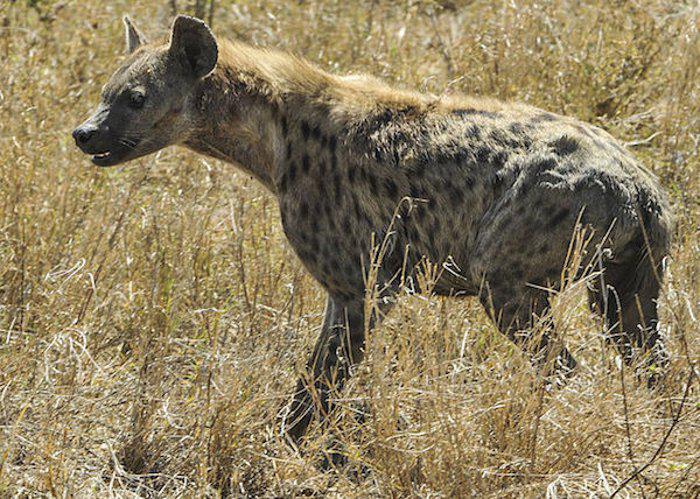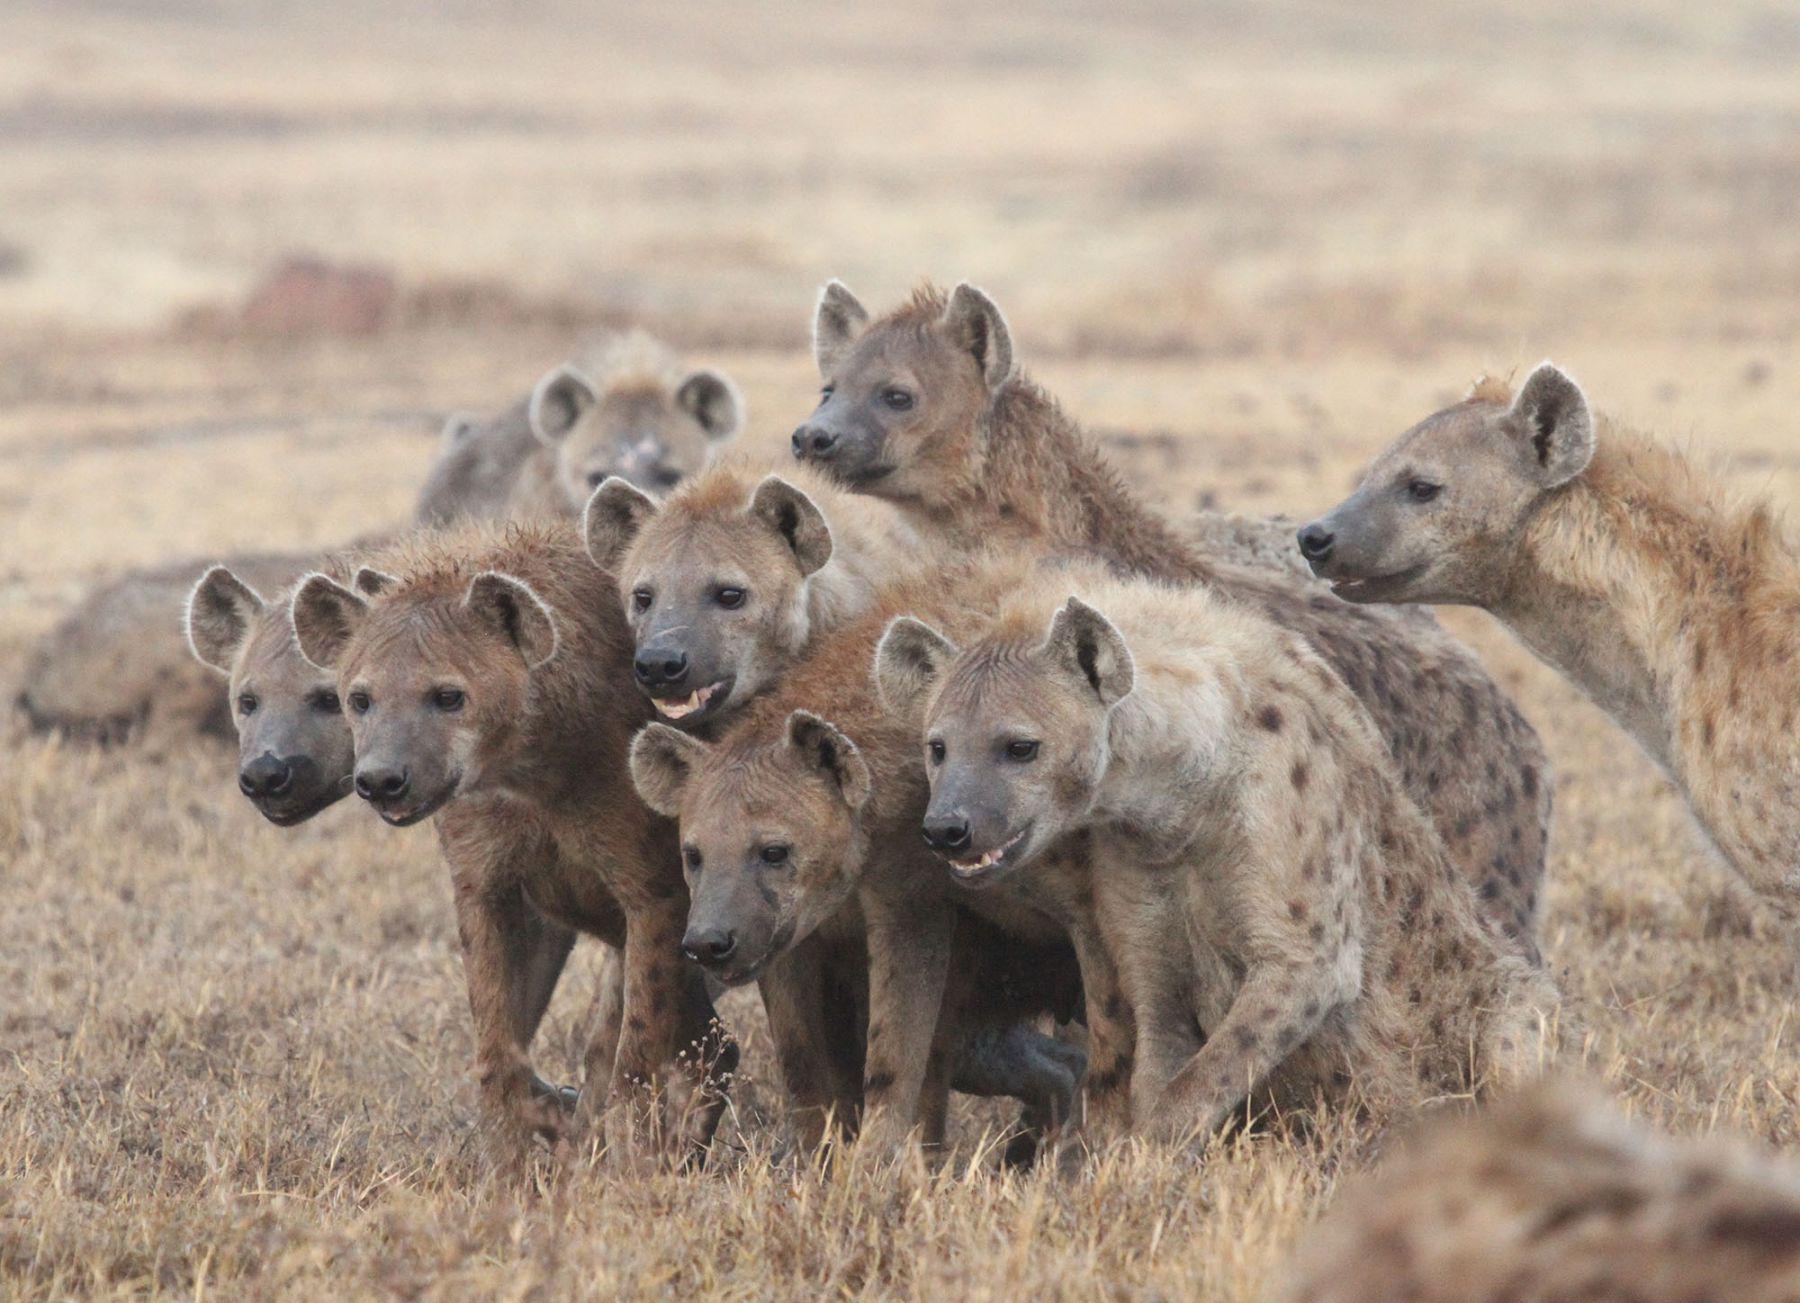The first image is the image on the left, the second image is the image on the right. Examine the images to the left and right. Is the description "Two hyenas are visible." accurate? Answer yes or no. No. The first image is the image on the left, the second image is the image on the right. Considering the images on both sides, is "There is at least one hyena laying on the ground." valid? Answer yes or no. No. 